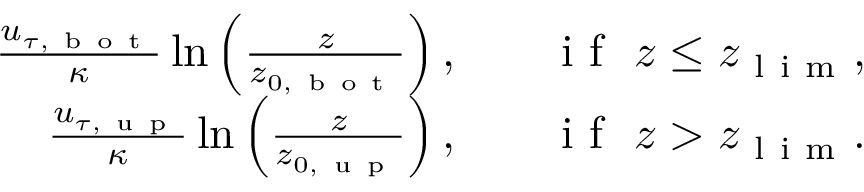<formula> <loc_0><loc_0><loc_500><loc_500>\begin{array} { r l r } { \frac { u _ { \tau , b o t } } { \kappa } \ln \left ( \frac { z } { z _ { 0 , b o t } } \right ) , } & { i f \ z \leq z _ { l i m } , } \\ { \frac { u _ { \tau , u p } } { \kappa } \ln \left ( \frac { z } { z _ { 0 , u p } } \right ) , } & { i f \ z > z _ { l i m } . } \end{array}</formula> 